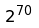Convert formula to latex. <formula><loc_0><loc_0><loc_500><loc_500>2 ^ { 7 0 }</formula> 